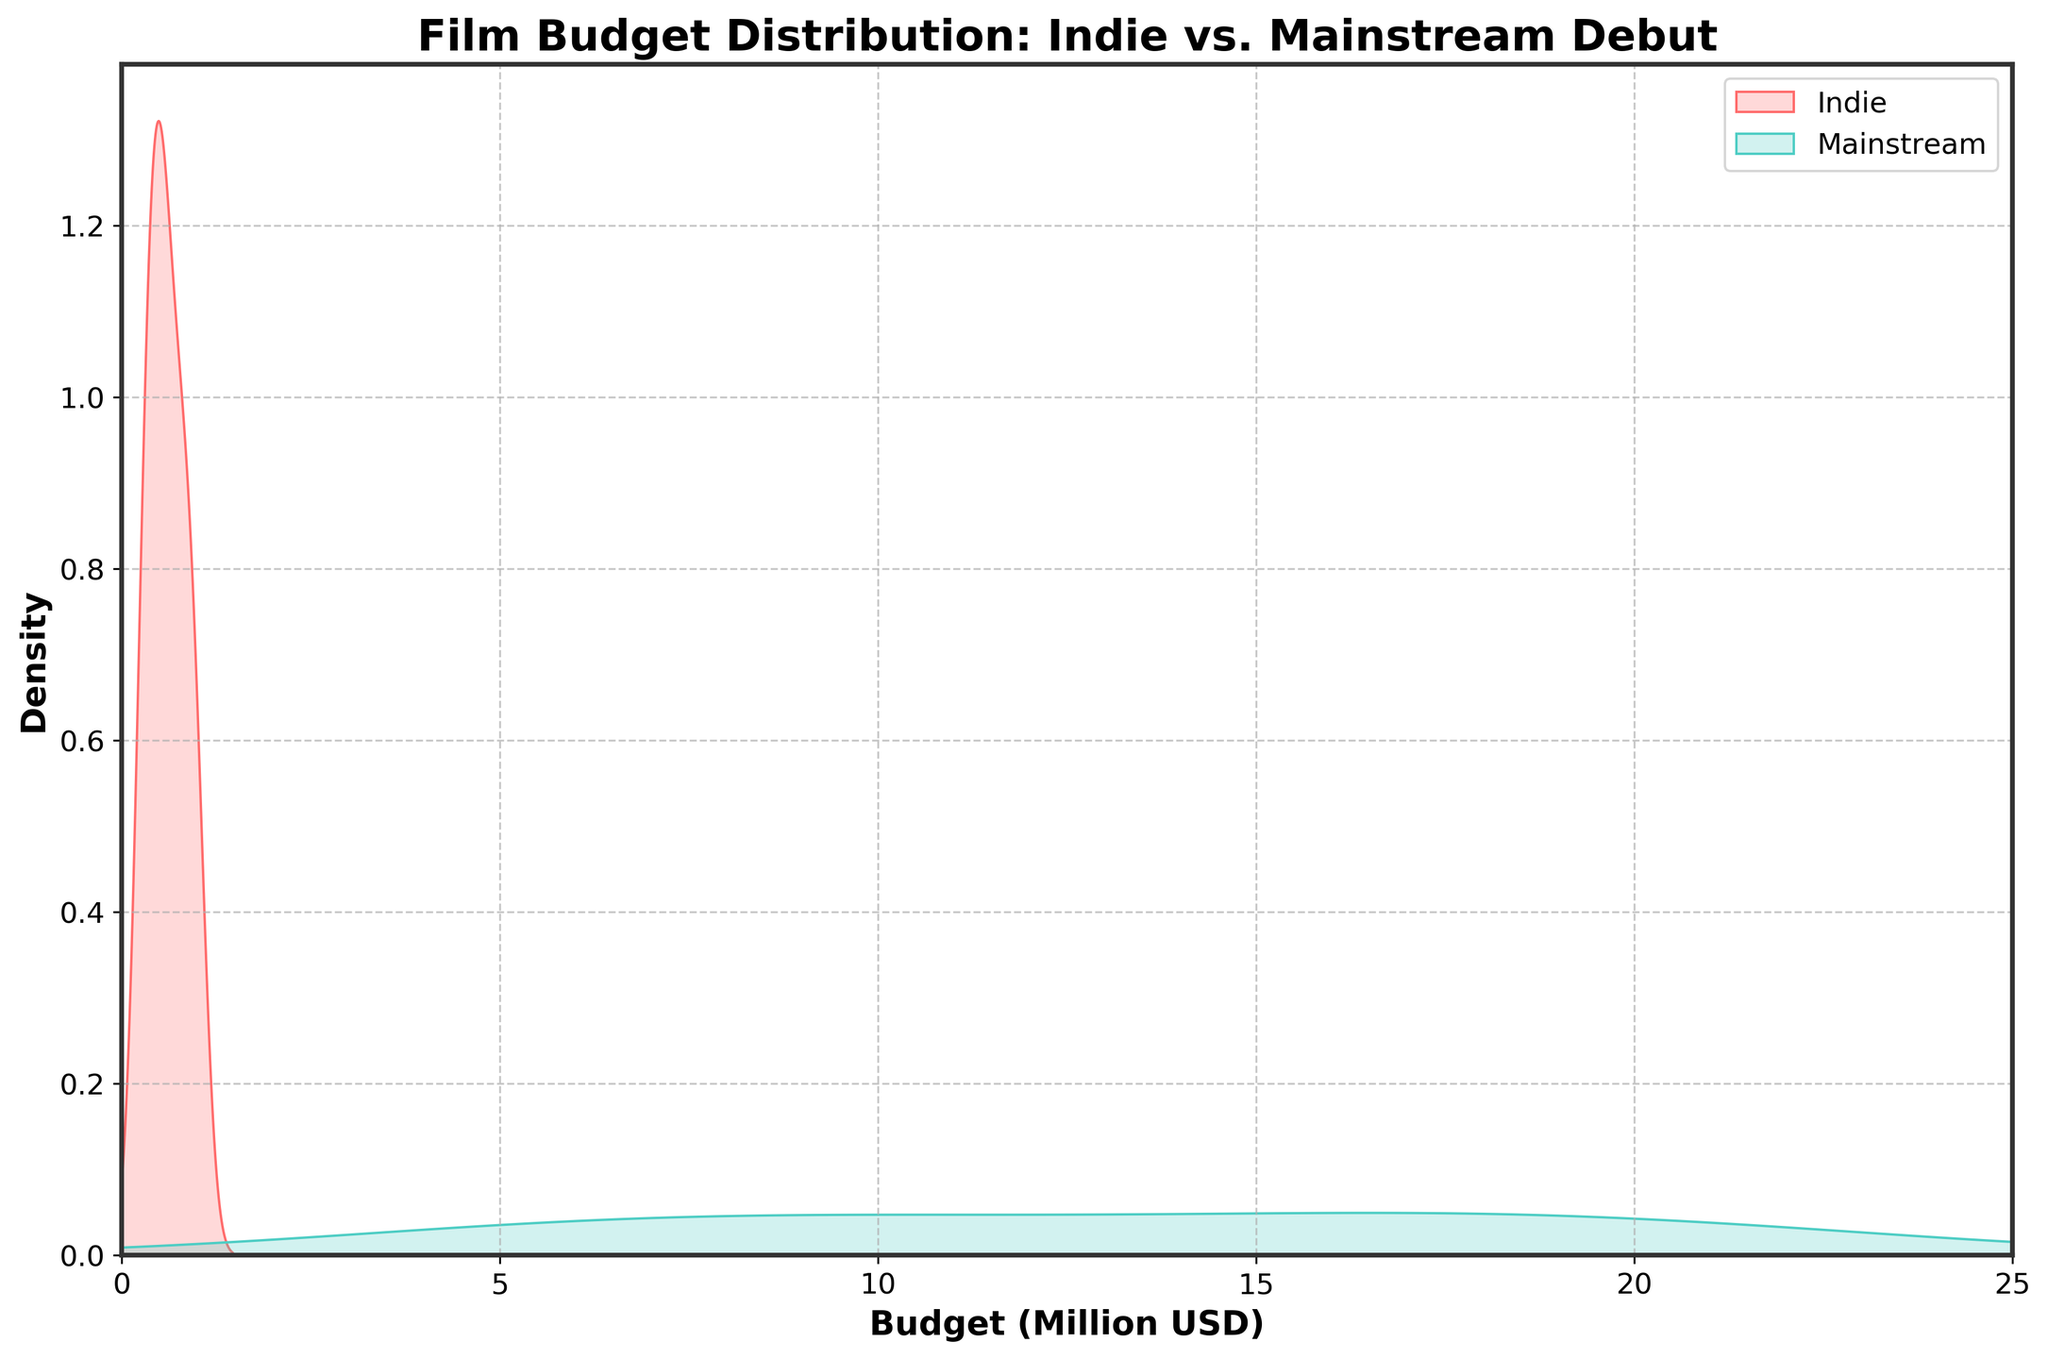How many colors are used to represent the two types of films in the plot? The plot uses two different shades to represent "Indie" and "Mainstream" films, specifically a shade of red for "Indie" and a shade of green for "Mainstream".
Answer: Two What is the title of the plot? The title is displayed at the top of the figure. It reads "Film Budget Distribution: Indie vs. Mainstream Debut".
Answer: "Film Budget Distribution: Indie vs. Mainstream Debut" What is the maximum value on the x-axis representing the film budgets? The x-axis ranges from 0 to 25, with the maximum value shown as 25.
Answer: 25 Which film type has a peak density value at a lower budget range? By observing the plot, the peak density for "Indie" films occurs at a lower budget range compared to "Mainstream".
Answer: Indie How does the central tendency of indie films' budgets compare to mainstream films' budgets? Indie films' budgets tend to concentrate around a lower budget range, while mainstream films’ budgets have higher central tendency values as observed from the density peaks.
Answer: Indie films have lower central tendency What is the x-axis label of the plot? The label on the x-axis states the category measured, which is "Budget (Million USD)".
Answer: Budget (Million USD) Are there more indie films or mainstream films within a budget range of 0 to 5 million USD? By inspecting the density curves, the density is substantially higher for indie films within the 0 to 5 million USD range compared to mainstream films.
Answer: Indie films What is the general spread of budgets for mainstream films? Mainstream films have a wider spread of budgets as indicated by the density spreading more evenly over a larger budget range.
Answer: Wider spread Do indie films and mainstream films have notably different budget distributions? The density curves show that indie films have a much narrower distribution centered around lower budgets, while mainstream films have a broader and more even spread.
Answer: Yes What is the label used for the vertical axis, which represents the density of budgets? The vertical axis is labeled “Density”, indicating it measures the density of the budgets.
Answer: Density 